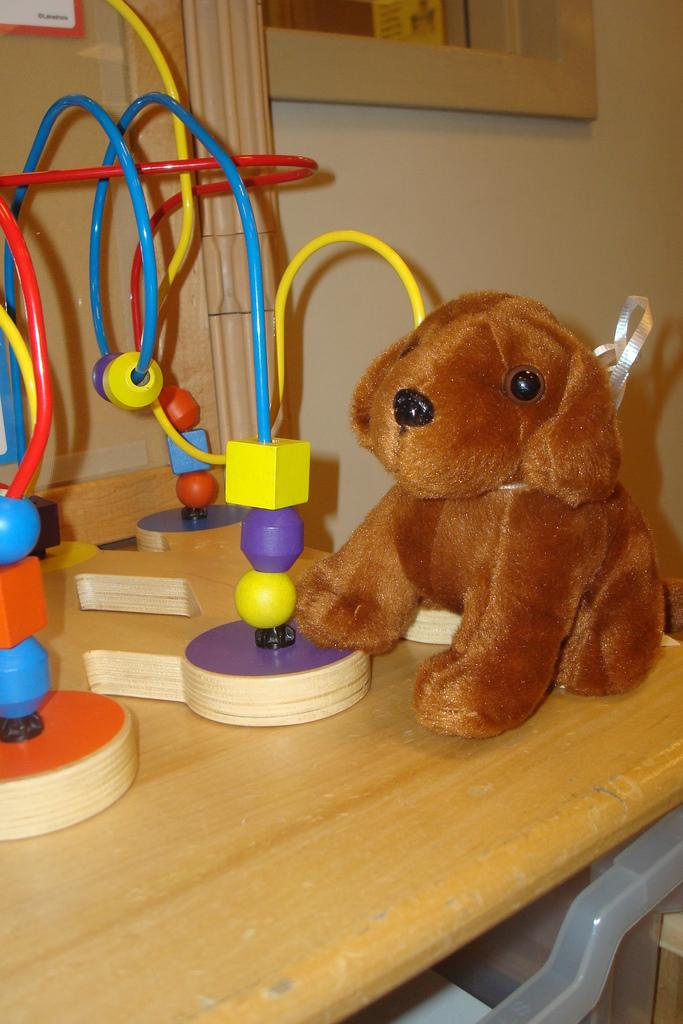What is the color of the toy in the image? The toy in the image is brown. What can be seen on the table in the image? There are colorful objects on the table. What is visible in the background of the image? There is a wall visible in the image. Can you describe any other objects in the image? Yes, there are additional objects in the image. How does the jellyfish interact with the chain in the image? There is no jellyfish or chain present in the image. 